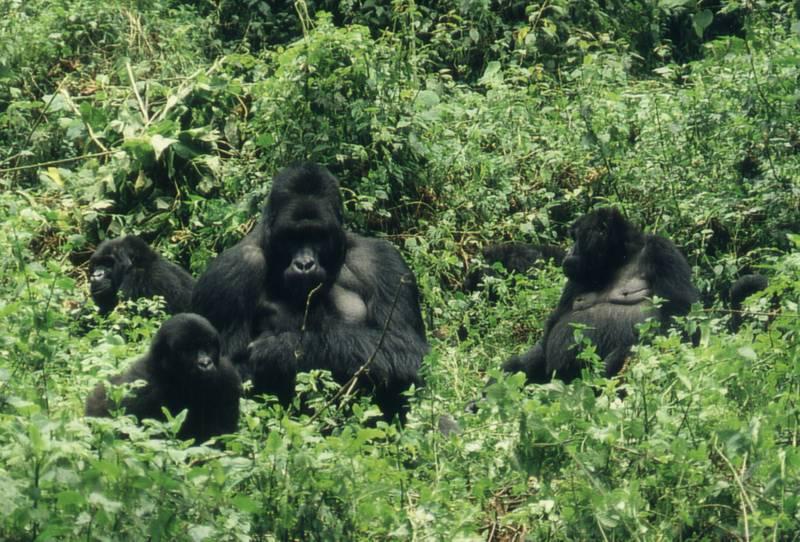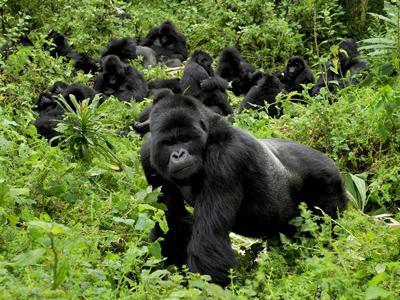The first image is the image on the left, the second image is the image on the right. Evaluate the accuracy of this statement regarding the images: "Each image includes a baby gorilla close to an adult gorilla who is facing leftward.". Is it true? Answer yes or no. No. 